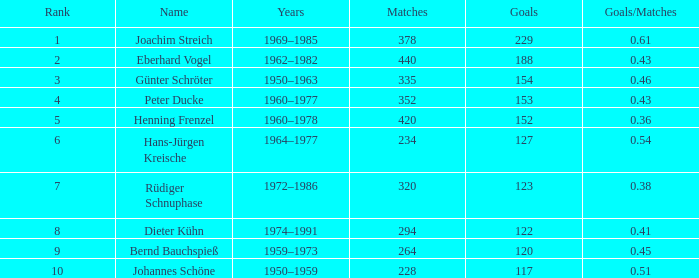What are the lowest goal that have goals/matches greater than 0.43 with joachim streich as the name and matches greater than 378? None. 